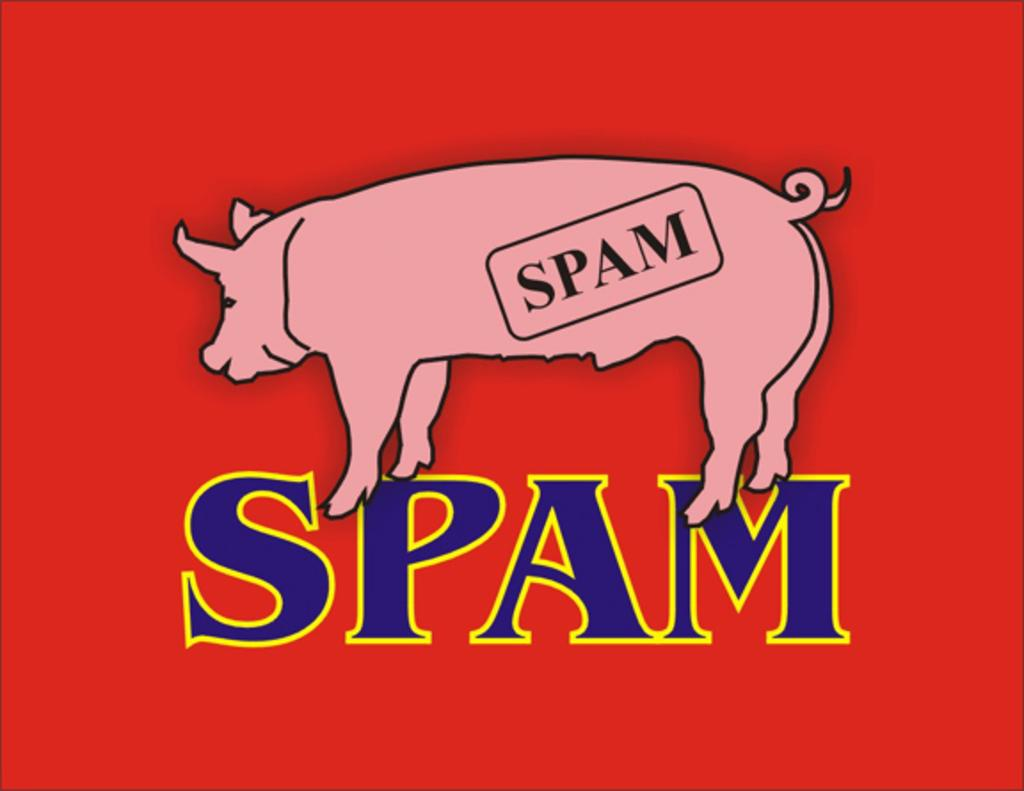What type of character is featured in the image? There is an animated animal in the image. What color is the background of the image? The background of the image is red. What else can be seen on the image besides the animated animal? There is text on the image. What type of bird is sitting on the book in the image? There is no bird or book present in the image; it features an animated animal and text on a red background. 